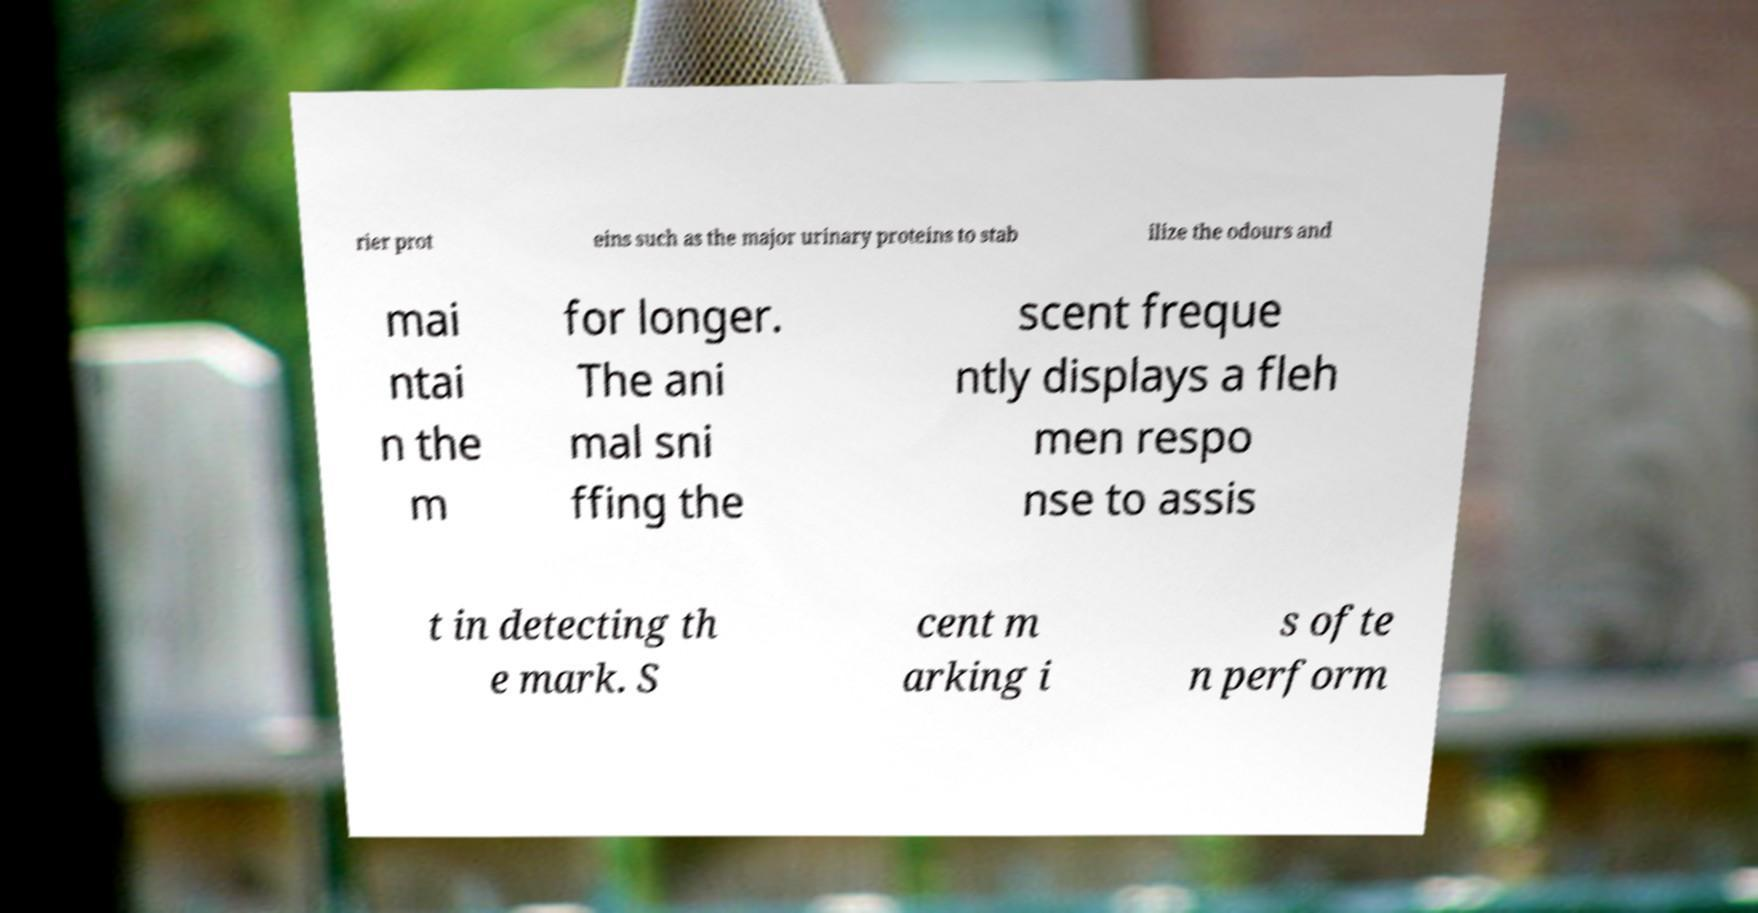Could you extract and type out the text from this image? rier prot eins such as the major urinary proteins to stab ilize the odours and mai ntai n the m for longer. The ani mal sni ffing the scent freque ntly displays a fleh men respo nse to assis t in detecting th e mark. S cent m arking i s ofte n perform 